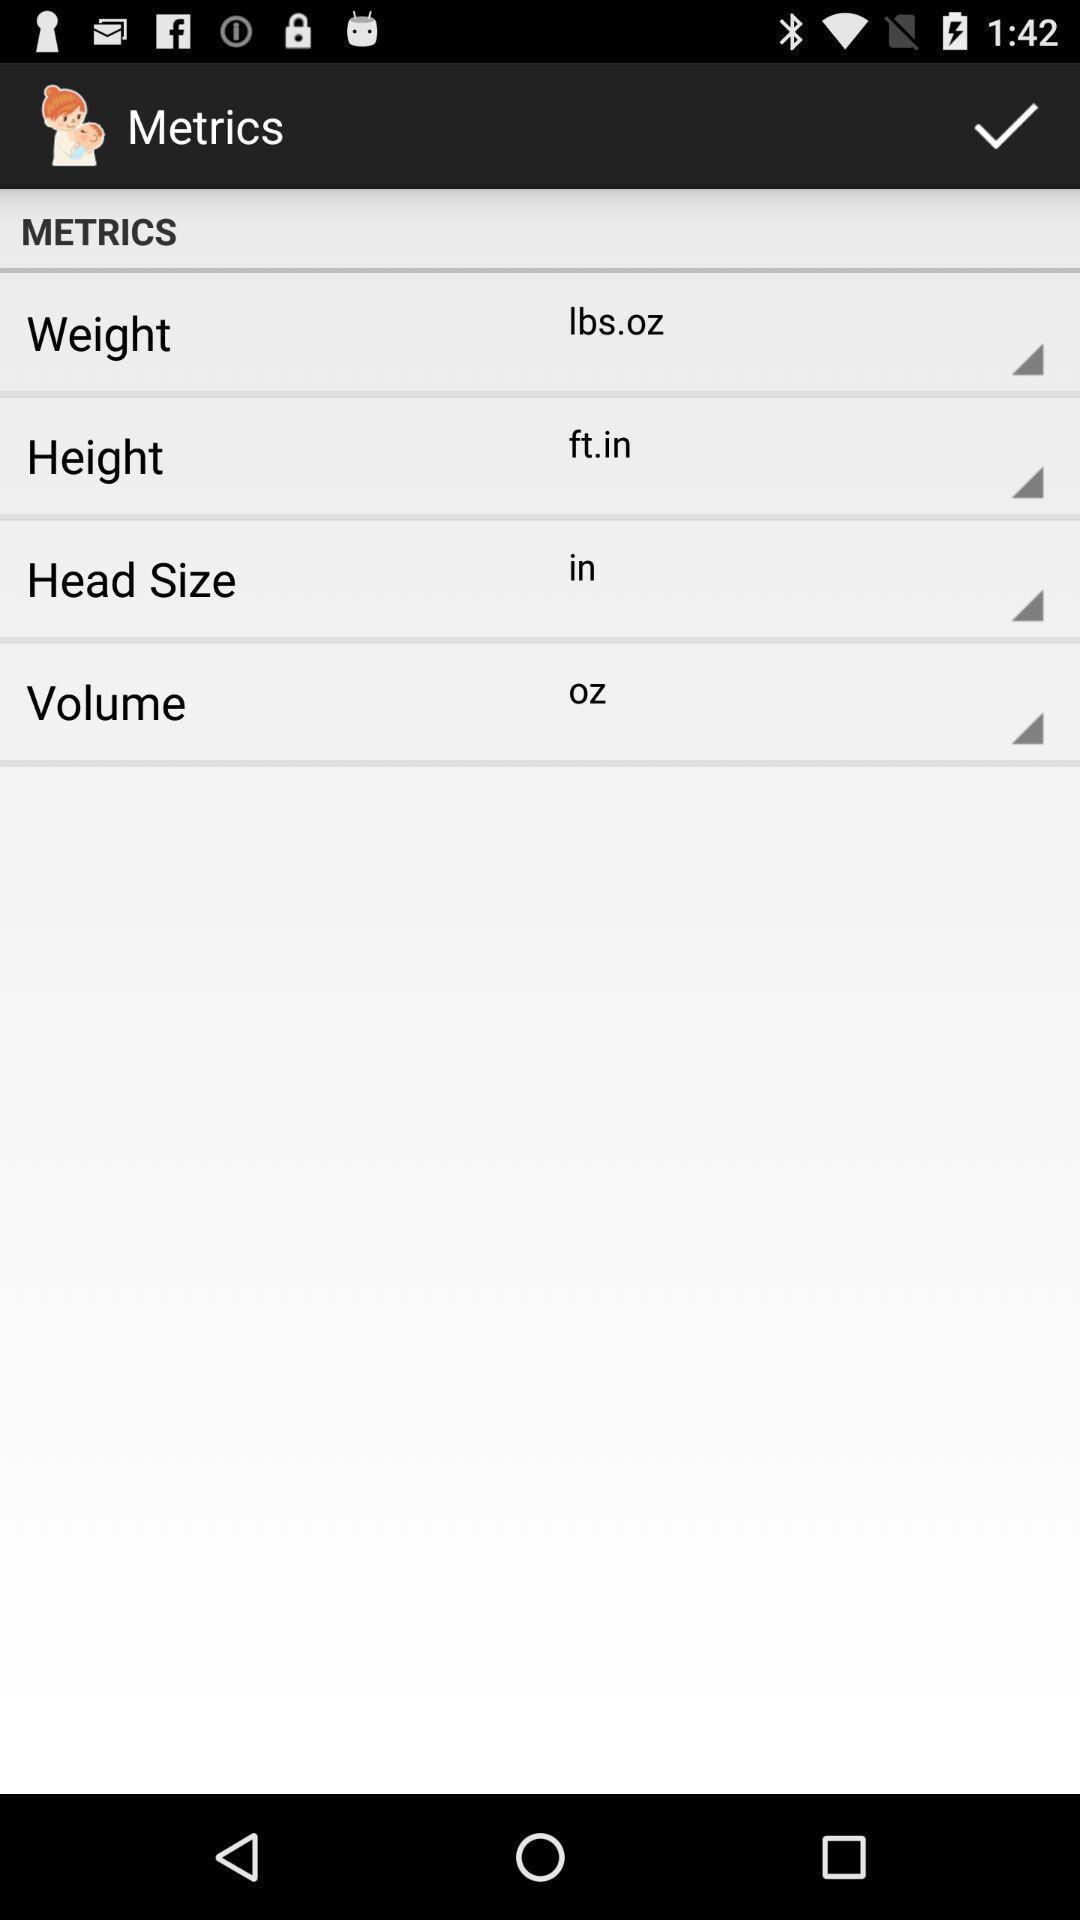Provide a detailed account of this screenshot. Screen shows multiple options. 